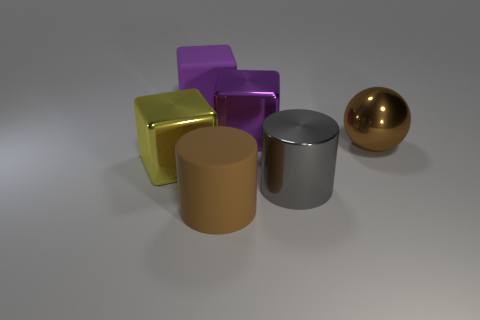What number of other big balls have the same color as the big metal ball?
Your answer should be compact. 0. Are there any other things that are the same shape as the brown shiny object?
Provide a short and direct response. No. How many cubes are brown rubber objects or big purple metal objects?
Your answer should be compact. 1. What is the color of the big metallic thing that is on the left side of the large rubber cylinder?
Give a very brief answer. Yellow. What is the shape of the yellow shiny thing that is the same size as the brown rubber object?
Your response must be concise. Cube. There is a gray shiny cylinder; what number of brown things are behind it?
Give a very brief answer. 1. How many things are large cylinders or gray metal cylinders?
Give a very brief answer. 2. There is a big object that is in front of the yellow object and on the left side of the large metallic cylinder; what is its shape?
Ensure brevity in your answer.  Cylinder. How many big purple metal things are there?
Make the answer very short. 1. The thing that is made of the same material as the big brown cylinder is what color?
Give a very brief answer. Purple. 